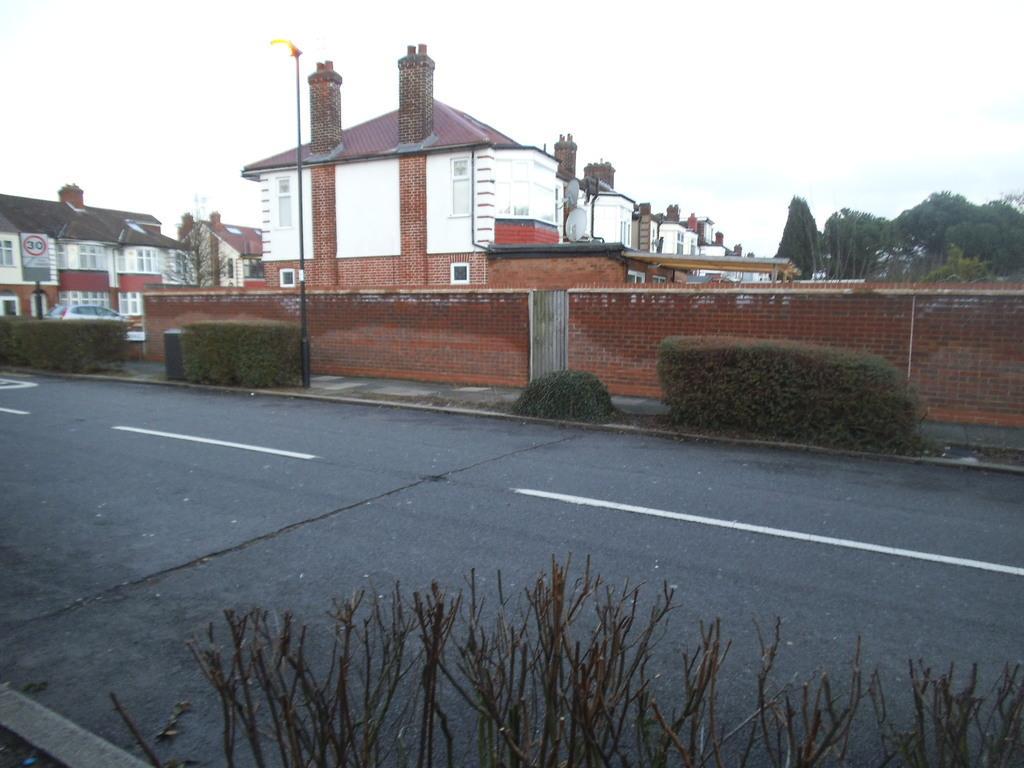In one or two sentences, can you explain what this image depicts? At the bottom of the picture, we see the plants and the road. In the middle, we see the hedging plants, garbage bin and a street light. Behind that, we see the wall which is made up of the bricks. There are trees and the buildings in the background. At the top, we see the sky. 